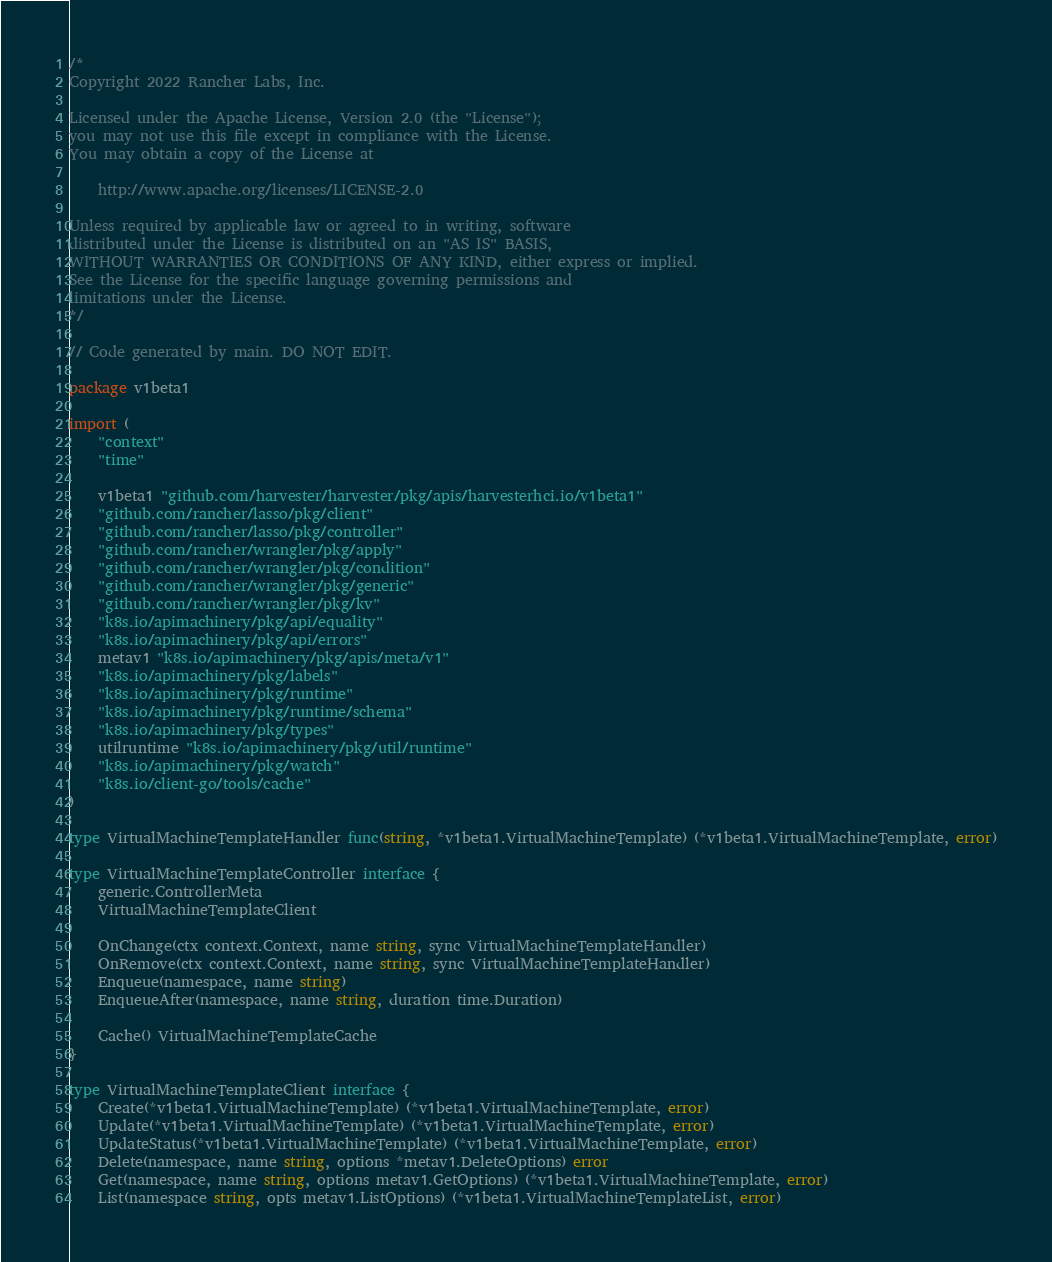<code> <loc_0><loc_0><loc_500><loc_500><_Go_>/*
Copyright 2022 Rancher Labs, Inc.

Licensed under the Apache License, Version 2.0 (the "License");
you may not use this file except in compliance with the License.
You may obtain a copy of the License at

    http://www.apache.org/licenses/LICENSE-2.0

Unless required by applicable law or agreed to in writing, software
distributed under the License is distributed on an "AS IS" BASIS,
WITHOUT WARRANTIES OR CONDITIONS OF ANY KIND, either express or implied.
See the License for the specific language governing permissions and
limitations under the License.
*/

// Code generated by main. DO NOT EDIT.

package v1beta1

import (
	"context"
	"time"

	v1beta1 "github.com/harvester/harvester/pkg/apis/harvesterhci.io/v1beta1"
	"github.com/rancher/lasso/pkg/client"
	"github.com/rancher/lasso/pkg/controller"
	"github.com/rancher/wrangler/pkg/apply"
	"github.com/rancher/wrangler/pkg/condition"
	"github.com/rancher/wrangler/pkg/generic"
	"github.com/rancher/wrangler/pkg/kv"
	"k8s.io/apimachinery/pkg/api/equality"
	"k8s.io/apimachinery/pkg/api/errors"
	metav1 "k8s.io/apimachinery/pkg/apis/meta/v1"
	"k8s.io/apimachinery/pkg/labels"
	"k8s.io/apimachinery/pkg/runtime"
	"k8s.io/apimachinery/pkg/runtime/schema"
	"k8s.io/apimachinery/pkg/types"
	utilruntime "k8s.io/apimachinery/pkg/util/runtime"
	"k8s.io/apimachinery/pkg/watch"
	"k8s.io/client-go/tools/cache"
)

type VirtualMachineTemplateHandler func(string, *v1beta1.VirtualMachineTemplate) (*v1beta1.VirtualMachineTemplate, error)

type VirtualMachineTemplateController interface {
	generic.ControllerMeta
	VirtualMachineTemplateClient

	OnChange(ctx context.Context, name string, sync VirtualMachineTemplateHandler)
	OnRemove(ctx context.Context, name string, sync VirtualMachineTemplateHandler)
	Enqueue(namespace, name string)
	EnqueueAfter(namespace, name string, duration time.Duration)

	Cache() VirtualMachineTemplateCache
}

type VirtualMachineTemplateClient interface {
	Create(*v1beta1.VirtualMachineTemplate) (*v1beta1.VirtualMachineTemplate, error)
	Update(*v1beta1.VirtualMachineTemplate) (*v1beta1.VirtualMachineTemplate, error)
	UpdateStatus(*v1beta1.VirtualMachineTemplate) (*v1beta1.VirtualMachineTemplate, error)
	Delete(namespace, name string, options *metav1.DeleteOptions) error
	Get(namespace, name string, options metav1.GetOptions) (*v1beta1.VirtualMachineTemplate, error)
	List(namespace string, opts metav1.ListOptions) (*v1beta1.VirtualMachineTemplateList, error)</code> 